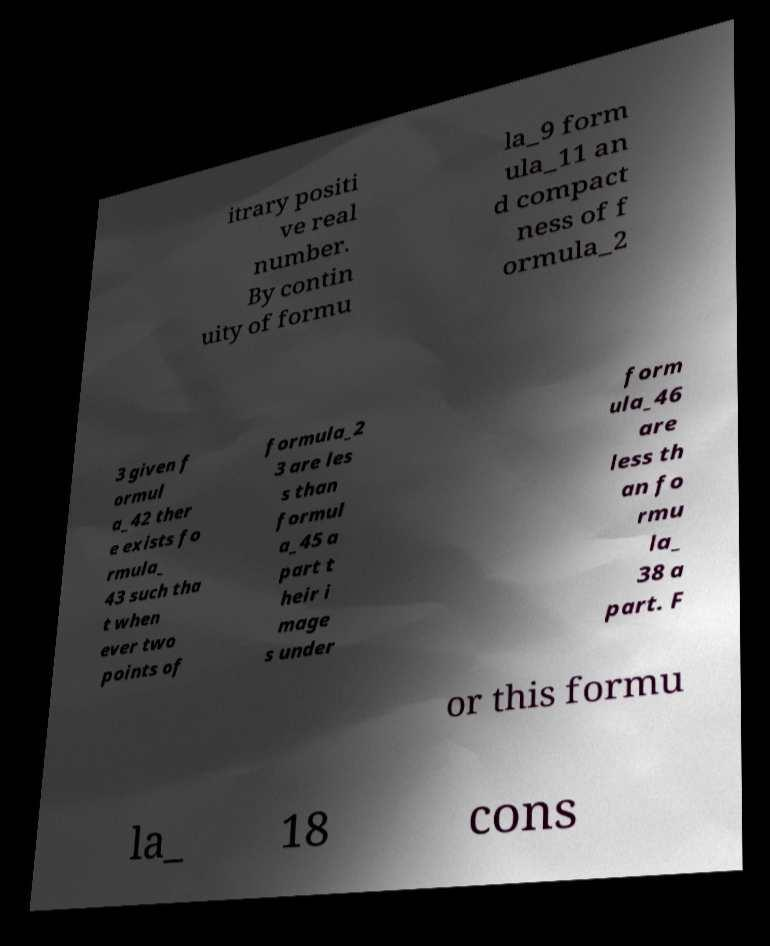I need the written content from this picture converted into text. Can you do that? itrary positi ve real number. By contin uity of formu la_9 form ula_11 an d compact ness of f ormula_2 3 given f ormul a_42 ther e exists fo rmula_ 43 such tha t when ever two points of formula_2 3 are les s than formul a_45 a part t heir i mage s under form ula_46 are less th an fo rmu la_ 38 a part. F or this formu la_ 18 cons 